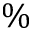<formula> <loc_0><loc_0><loc_500><loc_500>\%</formula> 